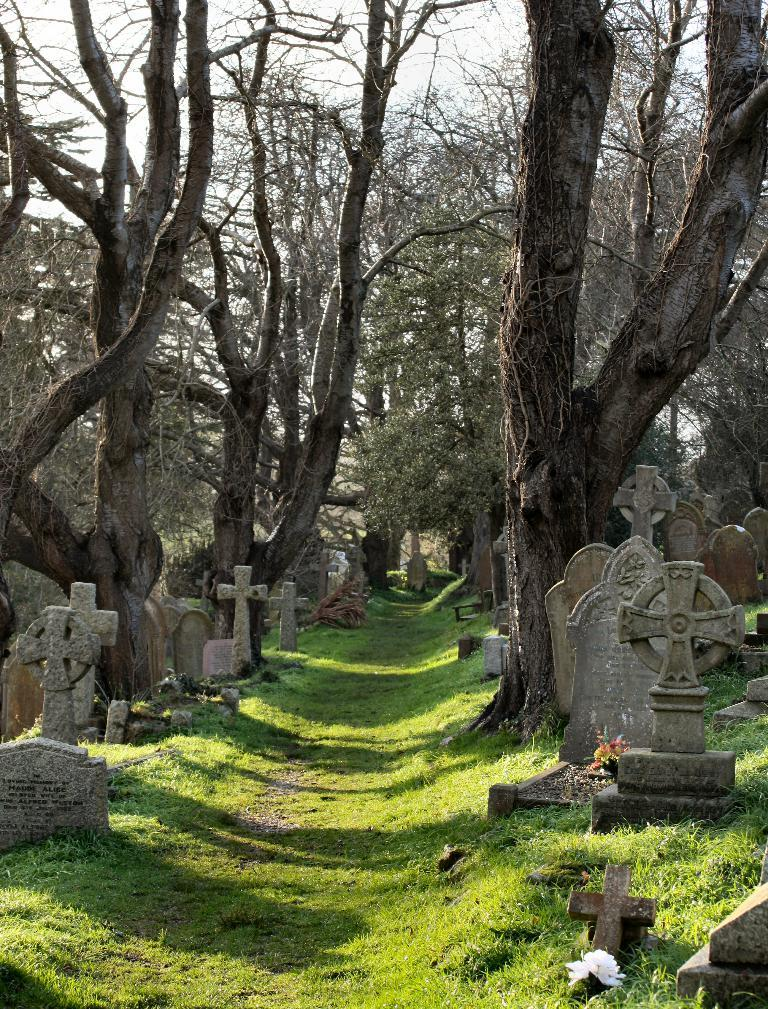What type of structures can be seen in the image? There are grave stones in the image. What type of plants are present in the image? There are flowers and grass in the image. What type of vegetation can be seen in the background of the image? There are trees in the image. What is visible in the sky in the image? The sky is visible in the image. What type of camera is being used to take the picture of the family in the image? There is no camera or family present in the image; it features grave stones, flowers, grass, trees, and the sky. 